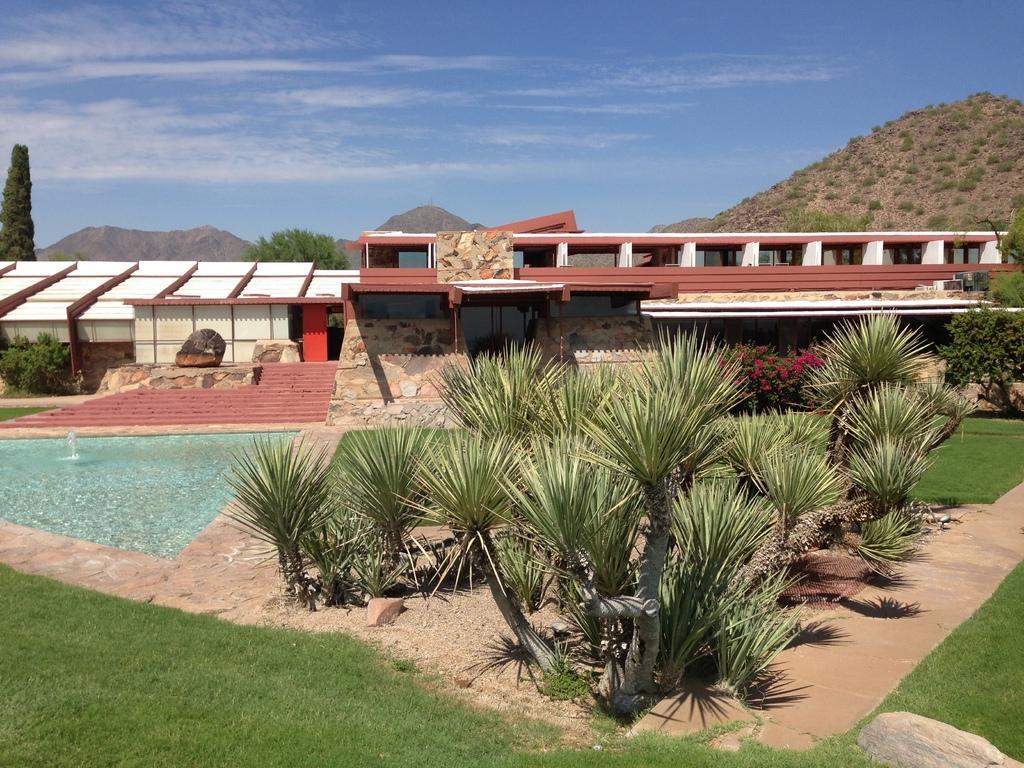In one or two sentences, can you explain what this image depicts? In this image we can see few trees, water, grass and stairs in front of the building and there are mountains, trees and the sky with clouds in the background. 